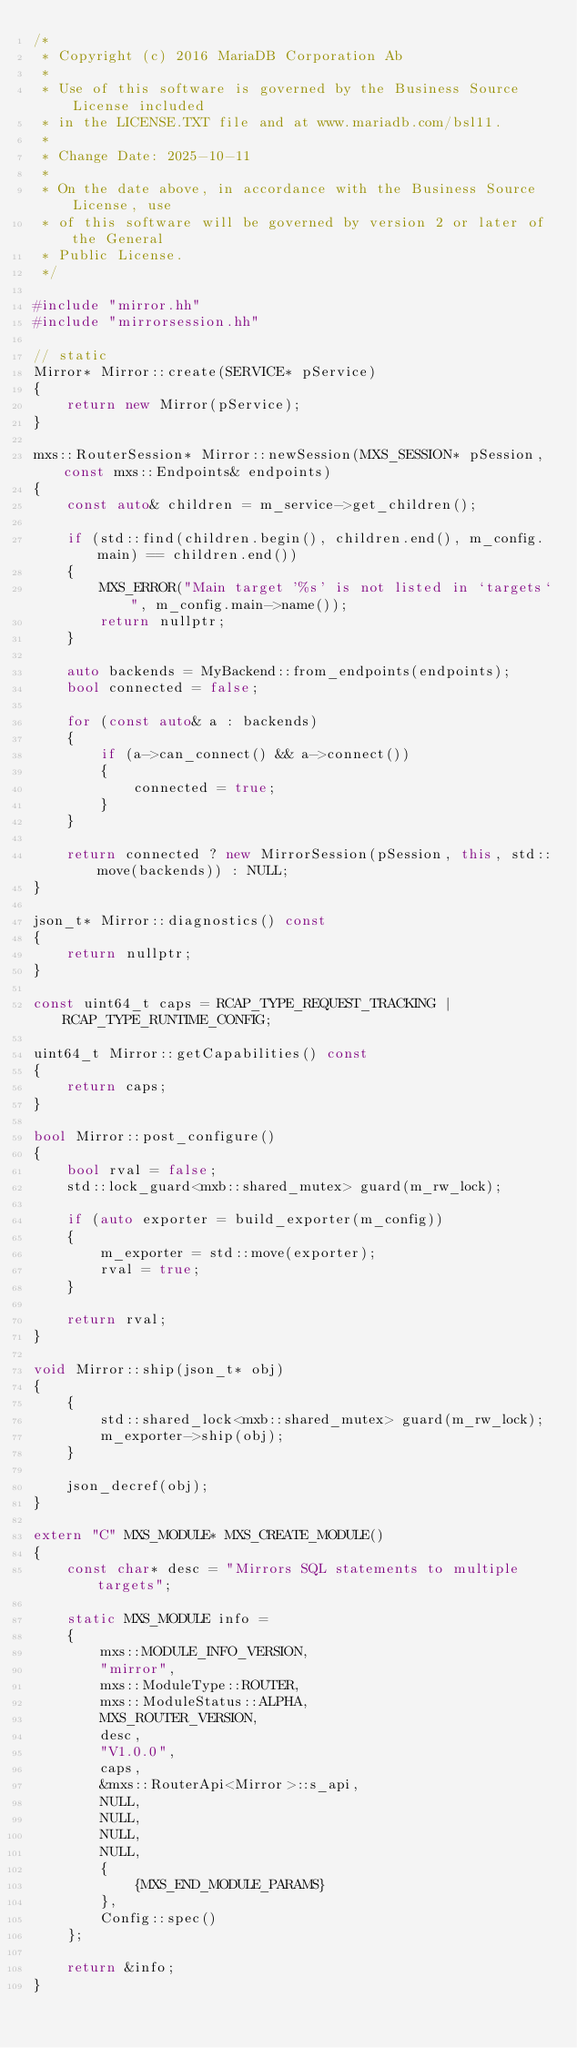<code> <loc_0><loc_0><loc_500><loc_500><_C++_>/*
 * Copyright (c) 2016 MariaDB Corporation Ab
 *
 * Use of this software is governed by the Business Source License included
 * in the LICENSE.TXT file and at www.mariadb.com/bsl11.
 *
 * Change Date: 2025-10-11
 *
 * On the date above, in accordance with the Business Source License, use
 * of this software will be governed by version 2 or later of the General
 * Public License.
 */

#include "mirror.hh"
#include "mirrorsession.hh"

// static
Mirror* Mirror::create(SERVICE* pService)
{
    return new Mirror(pService);
}

mxs::RouterSession* Mirror::newSession(MXS_SESSION* pSession, const mxs::Endpoints& endpoints)
{
    const auto& children = m_service->get_children();

    if (std::find(children.begin(), children.end(), m_config.main) == children.end())
    {
        MXS_ERROR("Main target '%s' is not listed in `targets`", m_config.main->name());
        return nullptr;
    }

    auto backends = MyBackend::from_endpoints(endpoints);
    bool connected = false;

    for (const auto& a : backends)
    {
        if (a->can_connect() && a->connect())
        {
            connected = true;
        }
    }

    return connected ? new MirrorSession(pSession, this, std::move(backends)) : NULL;
}

json_t* Mirror::diagnostics() const
{
    return nullptr;
}

const uint64_t caps = RCAP_TYPE_REQUEST_TRACKING | RCAP_TYPE_RUNTIME_CONFIG;

uint64_t Mirror::getCapabilities() const
{
    return caps;
}

bool Mirror::post_configure()
{
    bool rval = false;
    std::lock_guard<mxb::shared_mutex> guard(m_rw_lock);

    if (auto exporter = build_exporter(m_config))
    {
        m_exporter = std::move(exporter);
        rval = true;
    }

    return rval;
}

void Mirror::ship(json_t* obj)
{
    {
        std::shared_lock<mxb::shared_mutex> guard(m_rw_lock);
        m_exporter->ship(obj);
    }

    json_decref(obj);
}

extern "C" MXS_MODULE* MXS_CREATE_MODULE()
{
    const char* desc = "Mirrors SQL statements to multiple targets";

    static MXS_MODULE info =
    {
        mxs::MODULE_INFO_VERSION,
        "mirror",
        mxs::ModuleType::ROUTER,
        mxs::ModuleStatus::ALPHA,
        MXS_ROUTER_VERSION,
        desc,
        "V1.0.0",
        caps,
        &mxs::RouterApi<Mirror>::s_api,
        NULL,
        NULL,
        NULL,
        NULL,
        {
            {MXS_END_MODULE_PARAMS}
        },
        Config::spec()
    };

    return &info;
}
</code> 